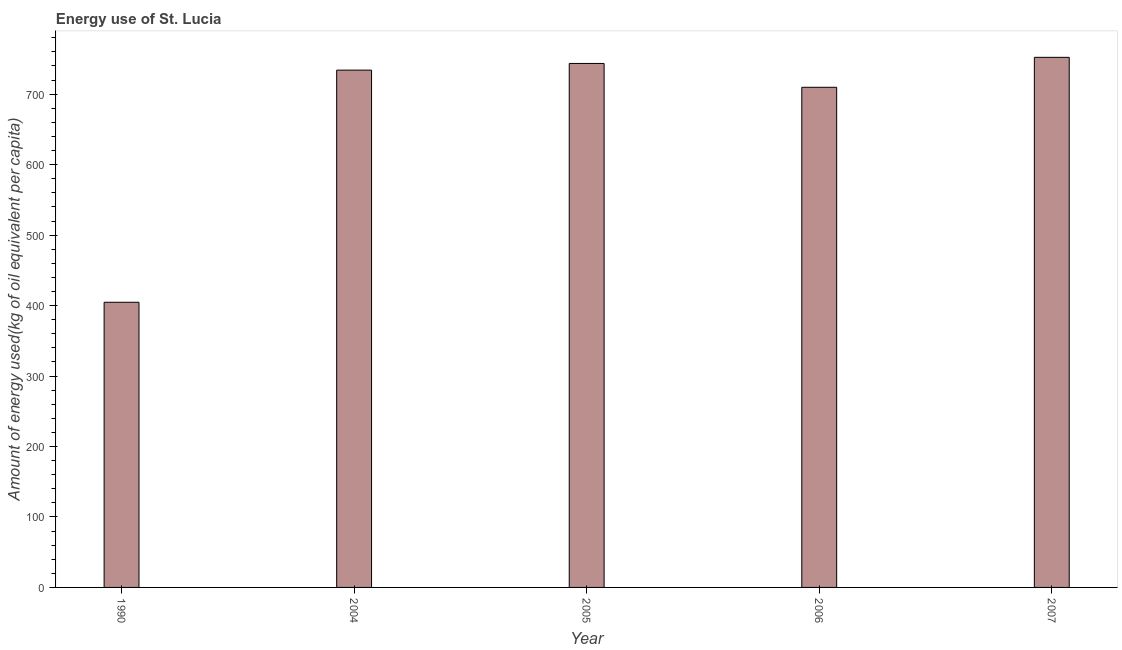Does the graph contain any zero values?
Offer a very short reply. No. What is the title of the graph?
Keep it short and to the point. Energy use of St. Lucia. What is the label or title of the Y-axis?
Your answer should be compact. Amount of energy used(kg of oil equivalent per capita). What is the amount of energy used in 1990?
Provide a succinct answer. 404.69. Across all years, what is the maximum amount of energy used?
Keep it short and to the point. 752.3. Across all years, what is the minimum amount of energy used?
Your answer should be very brief. 404.69. In which year was the amount of energy used maximum?
Offer a terse response. 2007. What is the sum of the amount of energy used?
Offer a very short reply. 3344.51. What is the difference between the amount of energy used in 2004 and 2007?
Your answer should be very brief. -18.18. What is the average amount of energy used per year?
Ensure brevity in your answer.  668.9. What is the median amount of energy used?
Your answer should be compact. 734.12. In how many years, is the amount of energy used greater than 660 kg?
Provide a short and direct response. 4. Do a majority of the years between 2004 and 2005 (inclusive) have amount of energy used greater than 660 kg?
Provide a succinct answer. Yes. What is the ratio of the amount of energy used in 2004 to that in 2007?
Your response must be concise. 0.98. Is the amount of energy used in 2004 less than that in 2005?
Ensure brevity in your answer.  Yes. Is the difference between the amount of energy used in 1990 and 2006 greater than the difference between any two years?
Give a very brief answer. No. What is the difference between the highest and the second highest amount of energy used?
Your answer should be compact. 8.68. What is the difference between the highest and the lowest amount of energy used?
Provide a succinct answer. 347.61. Are all the bars in the graph horizontal?
Your answer should be very brief. No. How many years are there in the graph?
Make the answer very short. 5. What is the difference between two consecutive major ticks on the Y-axis?
Your answer should be very brief. 100. Are the values on the major ticks of Y-axis written in scientific E-notation?
Ensure brevity in your answer.  No. What is the Amount of energy used(kg of oil equivalent per capita) in 1990?
Provide a short and direct response. 404.69. What is the Amount of energy used(kg of oil equivalent per capita) of 2004?
Your answer should be compact. 734.12. What is the Amount of energy used(kg of oil equivalent per capita) of 2005?
Offer a very short reply. 743.62. What is the Amount of energy used(kg of oil equivalent per capita) of 2006?
Ensure brevity in your answer.  709.79. What is the Amount of energy used(kg of oil equivalent per capita) in 2007?
Provide a short and direct response. 752.3. What is the difference between the Amount of energy used(kg of oil equivalent per capita) in 1990 and 2004?
Your answer should be very brief. -329.43. What is the difference between the Amount of energy used(kg of oil equivalent per capita) in 1990 and 2005?
Ensure brevity in your answer.  -338.93. What is the difference between the Amount of energy used(kg of oil equivalent per capita) in 1990 and 2006?
Give a very brief answer. -305.1. What is the difference between the Amount of energy used(kg of oil equivalent per capita) in 1990 and 2007?
Give a very brief answer. -347.61. What is the difference between the Amount of energy used(kg of oil equivalent per capita) in 2004 and 2005?
Your answer should be compact. -9.5. What is the difference between the Amount of energy used(kg of oil equivalent per capita) in 2004 and 2006?
Offer a terse response. 24.33. What is the difference between the Amount of energy used(kg of oil equivalent per capita) in 2004 and 2007?
Your answer should be compact. -18.18. What is the difference between the Amount of energy used(kg of oil equivalent per capita) in 2005 and 2006?
Offer a terse response. 33.83. What is the difference between the Amount of energy used(kg of oil equivalent per capita) in 2005 and 2007?
Your answer should be very brief. -8.67. What is the difference between the Amount of energy used(kg of oil equivalent per capita) in 2006 and 2007?
Offer a very short reply. -42.51. What is the ratio of the Amount of energy used(kg of oil equivalent per capita) in 1990 to that in 2004?
Keep it short and to the point. 0.55. What is the ratio of the Amount of energy used(kg of oil equivalent per capita) in 1990 to that in 2005?
Keep it short and to the point. 0.54. What is the ratio of the Amount of energy used(kg of oil equivalent per capita) in 1990 to that in 2006?
Offer a very short reply. 0.57. What is the ratio of the Amount of energy used(kg of oil equivalent per capita) in 1990 to that in 2007?
Your response must be concise. 0.54. What is the ratio of the Amount of energy used(kg of oil equivalent per capita) in 2004 to that in 2006?
Offer a very short reply. 1.03. What is the ratio of the Amount of energy used(kg of oil equivalent per capita) in 2005 to that in 2006?
Provide a short and direct response. 1.05. What is the ratio of the Amount of energy used(kg of oil equivalent per capita) in 2006 to that in 2007?
Your answer should be compact. 0.94. 